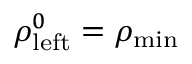Convert formula to latex. <formula><loc_0><loc_0><loc_500><loc_500>\rho _ { l e f t } ^ { 0 } = \rho _ { \min }</formula> 